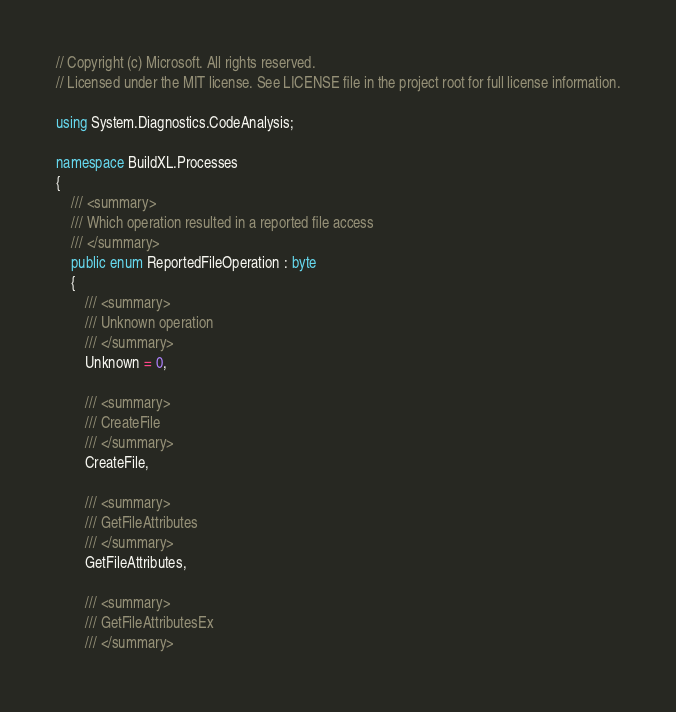Convert code to text. <code><loc_0><loc_0><loc_500><loc_500><_C#_>// Copyright (c) Microsoft. All rights reserved.
// Licensed under the MIT license. See LICENSE file in the project root for full license information.

using System.Diagnostics.CodeAnalysis;

namespace BuildXL.Processes
{
    /// <summary>
    /// Which operation resulted in a reported file access
    /// </summary>
    public enum ReportedFileOperation : byte
    {
        /// <summary>
        /// Unknown operation
        /// </summary>
        Unknown = 0,

        /// <summary>
        /// CreateFile
        /// </summary>
        CreateFile,

        /// <summary>
        /// GetFileAttributes
        /// </summary>
        GetFileAttributes,

        /// <summary>
        /// GetFileAttributesEx
        /// </summary></code> 